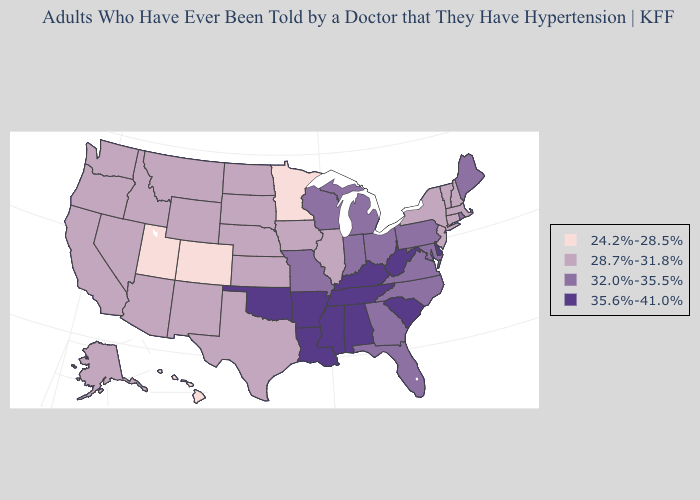Does Nevada have the lowest value in the West?
Write a very short answer. No. What is the highest value in the MidWest ?
Short answer required. 32.0%-35.5%. Name the states that have a value in the range 35.6%-41.0%?
Short answer required. Alabama, Arkansas, Delaware, Kentucky, Louisiana, Mississippi, Oklahoma, South Carolina, Tennessee, West Virginia. What is the highest value in the USA?
Keep it brief. 35.6%-41.0%. What is the lowest value in states that border West Virginia?
Answer briefly. 32.0%-35.5%. What is the value of Hawaii?
Be succinct. 24.2%-28.5%. What is the highest value in states that border Colorado?
Answer briefly. 35.6%-41.0%. Name the states that have a value in the range 28.7%-31.8%?
Keep it brief. Alaska, Arizona, California, Connecticut, Idaho, Illinois, Iowa, Kansas, Massachusetts, Montana, Nebraska, Nevada, New Hampshire, New Jersey, New Mexico, New York, North Dakota, Oregon, South Dakota, Texas, Vermont, Washington, Wyoming. What is the highest value in states that border South Carolina?
Quick response, please. 32.0%-35.5%. What is the value of Wisconsin?
Write a very short answer. 32.0%-35.5%. Does Utah have the lowest value in the USA?
Concise answer only. Yes. What is the lowest value in states that border New Hampshire?
Short answer required. 28.7%-31.8%. Does West Virginia have the highest value in the South?
Concise answer only. Yes. Name the states that have a value in the range 35.6%-41.0%?
Keep it brief. Alabama, Arkansas, Delaware, Kentucky, Louisiana, Mississippi, Oklahoma, South Carolina, Tennessee, West Virginia. What is the value of South Carolina?
Write a very short answer. 35.6%-41.0%. 